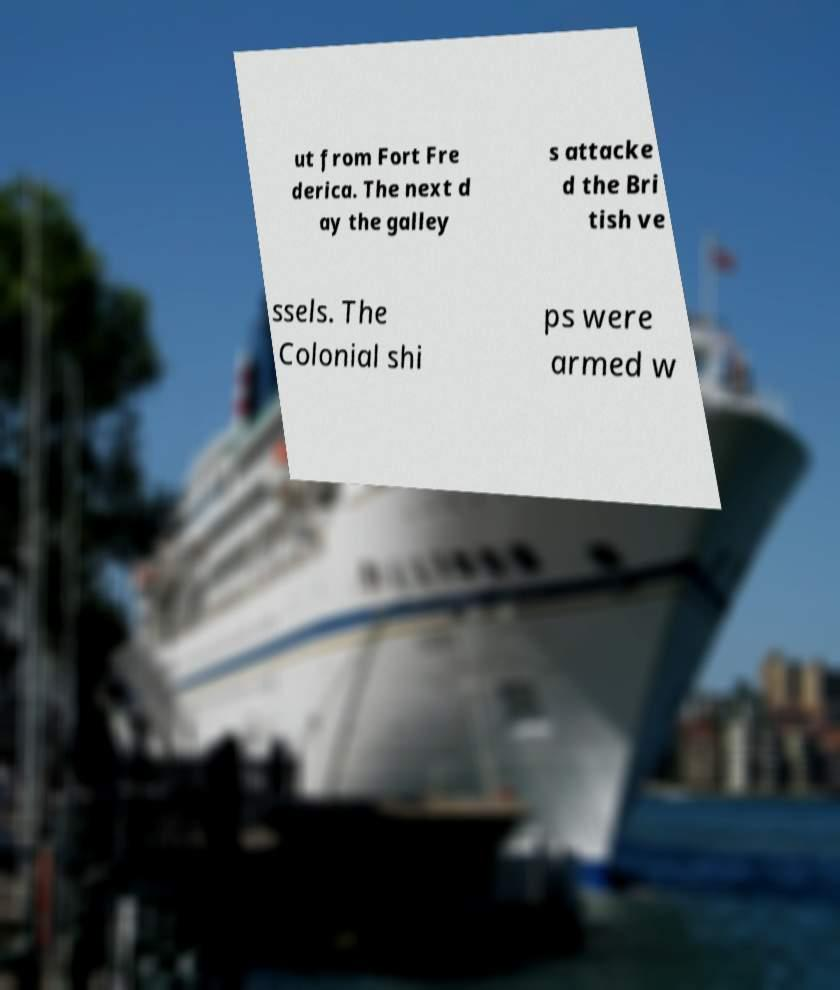Could you extract and type out the text from this image? ut from Fort Fre derica. The next d ay the galley s attacke d the Bri tish ve ssels. The Colonial shi ps were armed w 